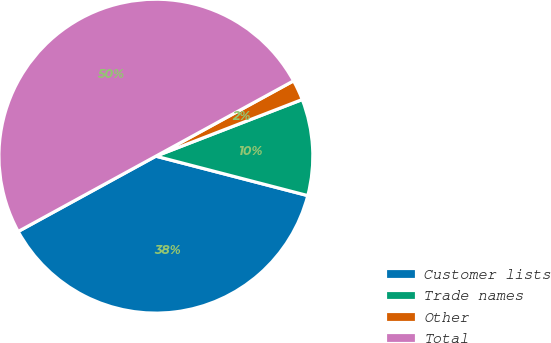<chart> <loc_0><loc_0><loc_500><loc_500><pie_chart><fcel>Customer lists<fcel>Trade names<fcel>Other<fcel>Total<nl><fcel>37.99%<fcel>9.92%<fcel>2.09%<fcel>50.0%<nl></chart> 